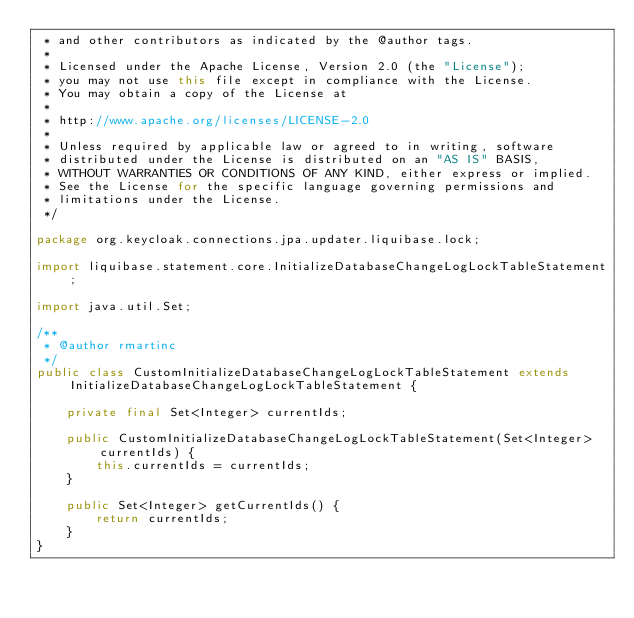<code> <loc_0><loc_0><loc_500><loc_500><_Java_> * and other contributors as indicated by the @author tags.
 *
 * Licensed under the Apache License, Version 2.0 (the "License");
 * you may not use this file except in compliance with the License.
 * You may obtain a copy of the License at
 *
 * http://www.apache.org/licenses/LICENSE-2.0
 *
 * Unless required by applicable law or agreed to in writing, software
 * distributed under the License is distributed on an "AS IS" BASIS,
 * WITHOUT WARRANTIES OR CONDITIONS OF ANY KIND, either express or implied.
 * See the License for the specific language governing permissions and
 * limitations under the License.
 */

package org.keycloak.connections.jpa.updater.liquibase.lock;

import liquibase.statement.core.InitializeDatabaseChangeLogLockTableStatement;

import java.util.Set;

/**
 * @author rmartinc
 */
public class CustomInitializeDatabaseChangeLogLockTableStatement extends InitializeDatabaseChangeLogLockTableStatement {

    private final Set<Integer> currentIds;

    public CustomInitializeDatabaseChangeLogLockTableStatement(Set<Integer> currentIds) {
        this.currentIds = currentIds;
    }

    public Set<Integer> getCurrentIds() {
        return currentIds;
    }
}</code> 